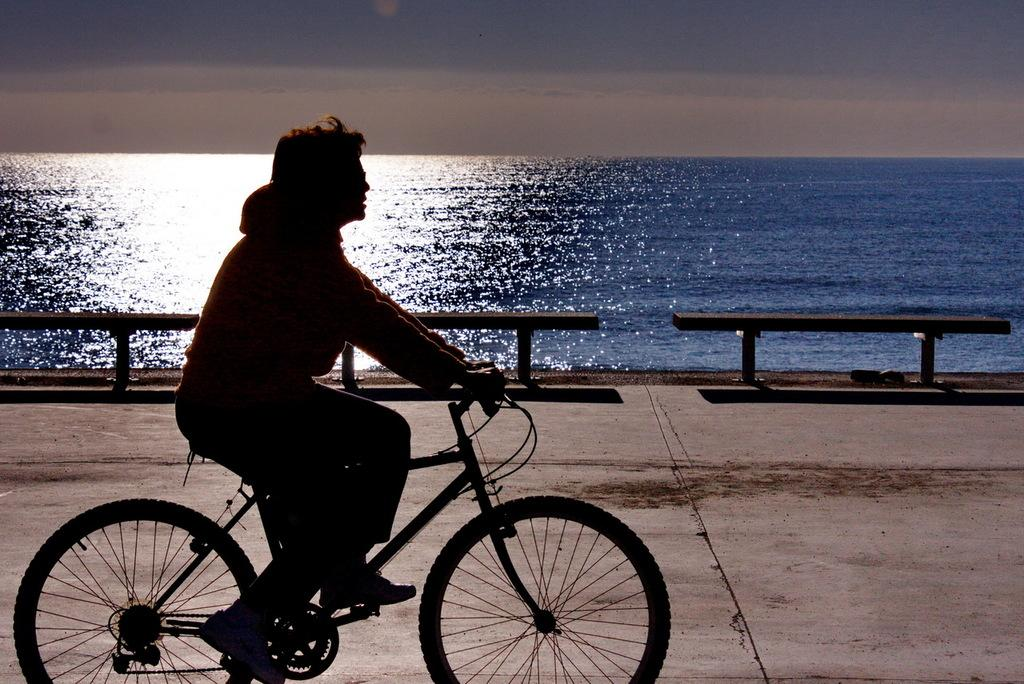What is the person in the image doing? There is a person riding a bicycle in the image. What can be seen in the corner of the road? There are three benches in the corner of the road. What type of location is depicted in the image? There is a beach in the image. What is the color of the sky in the image? The sky is blue in the image. Is there any sleet visible in the image? No, there is no sleet present in the image; the sky is blue, which suggests clear weather. What type of camp can be seen near the beach in the image? There is no camp present in the image; it only features a beach, a person riding a bicycle, and three benches. 